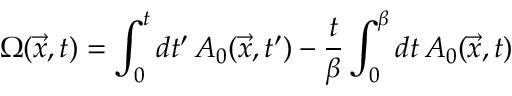<formula> <loc_0><loc_0><loc_500><loc_500>\Omega ( \vec { x } , t ) = \int _ { 0 } ^ { t } d t ^ { \prime } \, A _ { 0 } ( \vec { x } , t ^ { \prime } ) - { \frac { t } { \beta } } \int _ { 0 } ^ { \beta } d t \, A _ { 0 } ( \vec { x } , t )</formula> 